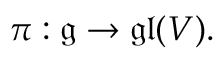Convert formula to latex. <formula><loc_0><loc_0><loc_500><loc_500>\pi \colon { \mathfrak { g } } \to { \mathfrak { g l } } ( V ) .</formula> 